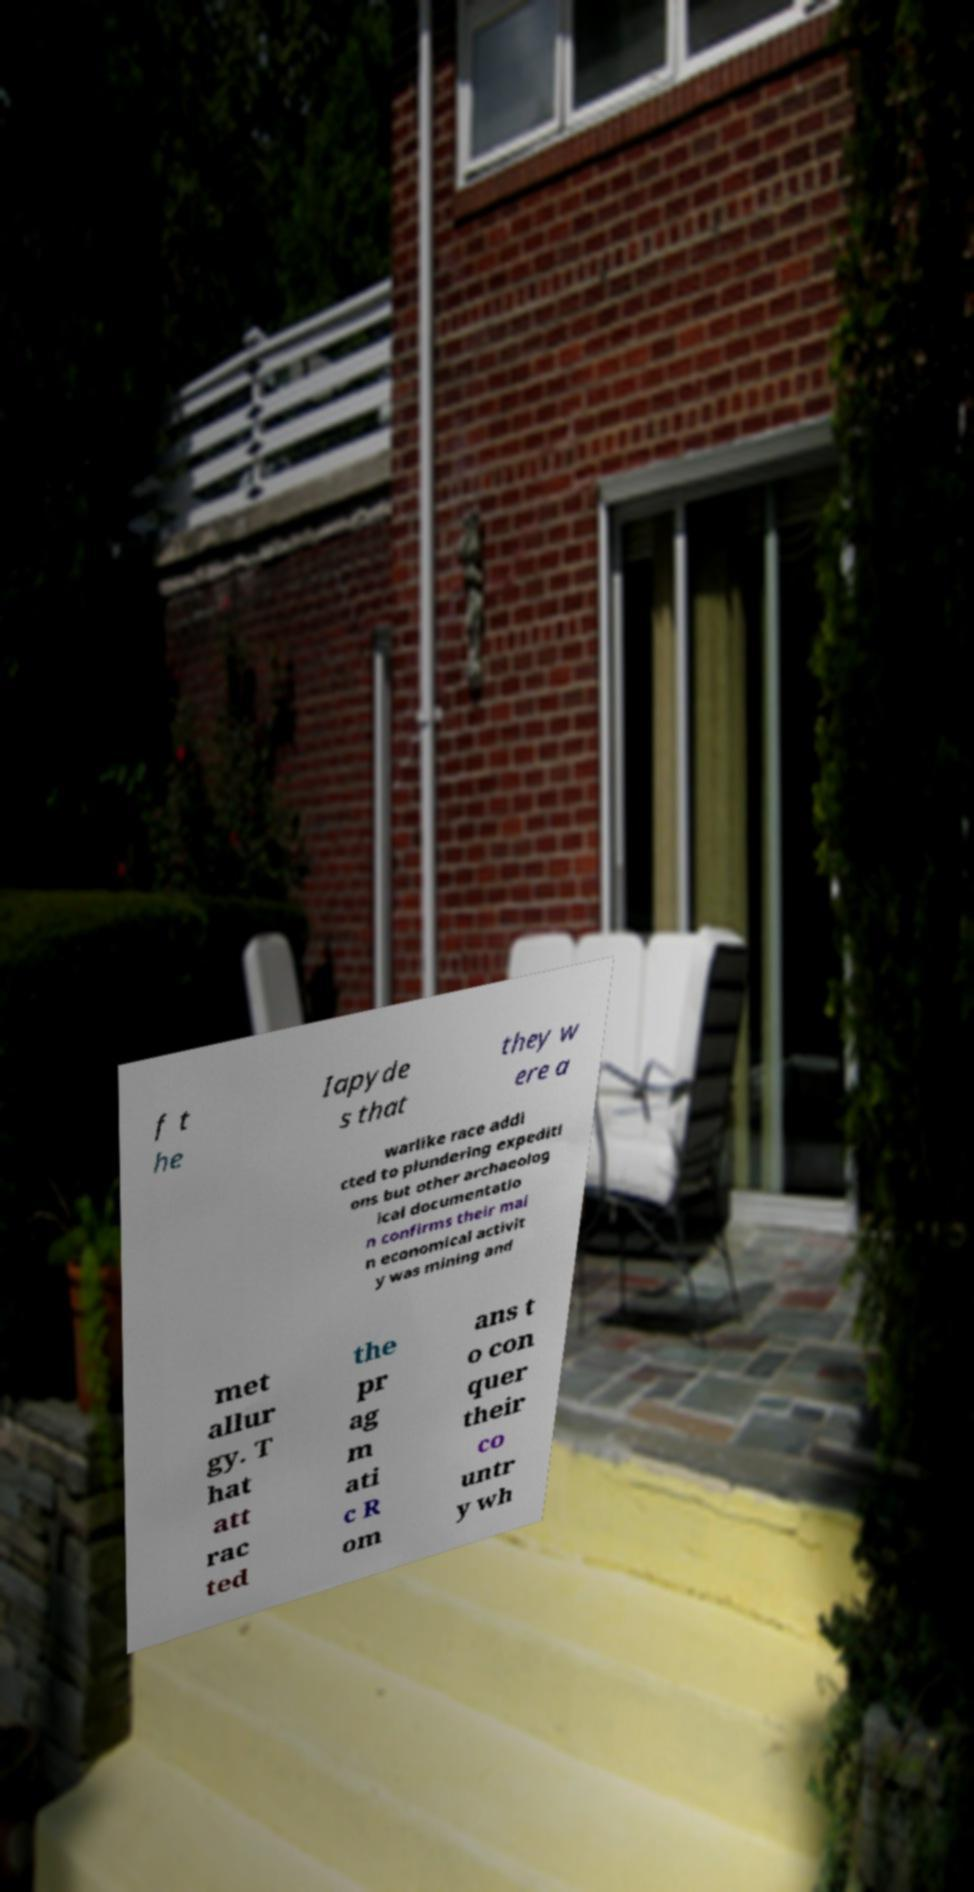I need the written content from this picture converted into text. Can you do that? f t he Iapyde s that they w ere a warlike race addi cted to plundering expediti ons but other archaeolog ical documentatio n confirms their mai n economical activit y was mining and met allur gy. T hat att rac ted the pr ag m ati c R om ans t o con quer their co untr y wh 